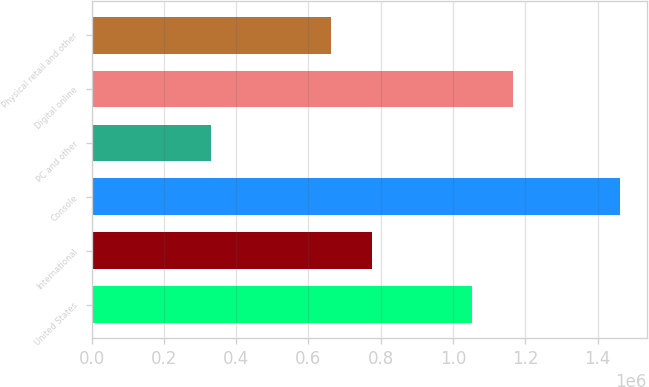<chart> <loc_0><loc_0><loc_500><loc_500><bar_chart><fcel>United States<fcel>International<fcel>Console<fcel>PC and other<fcel>Digital online<fcel>Physical retail and other<nl><fcel>1.05231e+06<fcel>775318<fcel>1.46331e+06<fcel>329586<fcel>1.16568e+06<fcel>661946<nl></chart> 